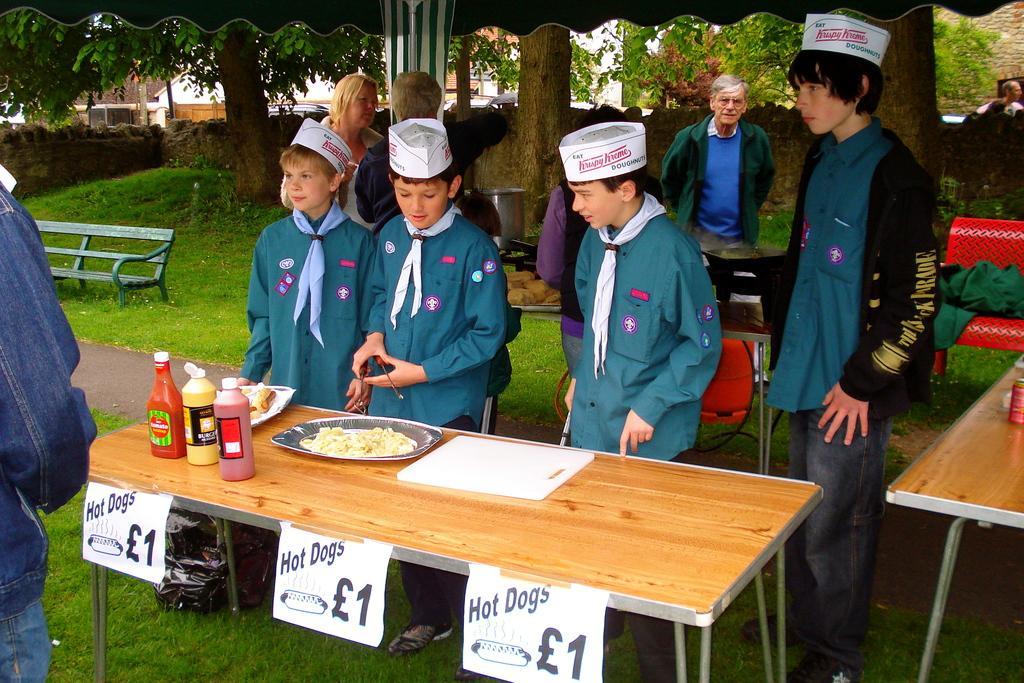Describe this image in one or two sentences. The picture is taken outside under a tent. There are four kids standing besides a table, on the table there is a plate, food and some bottles. There are some papers stick to the table and some text printed on it. All the kids are wearing blue shirts and white hats. Towards the left there is a man wearing a denim jacket and there is a bench. In the background there is a wall and group of trees. 